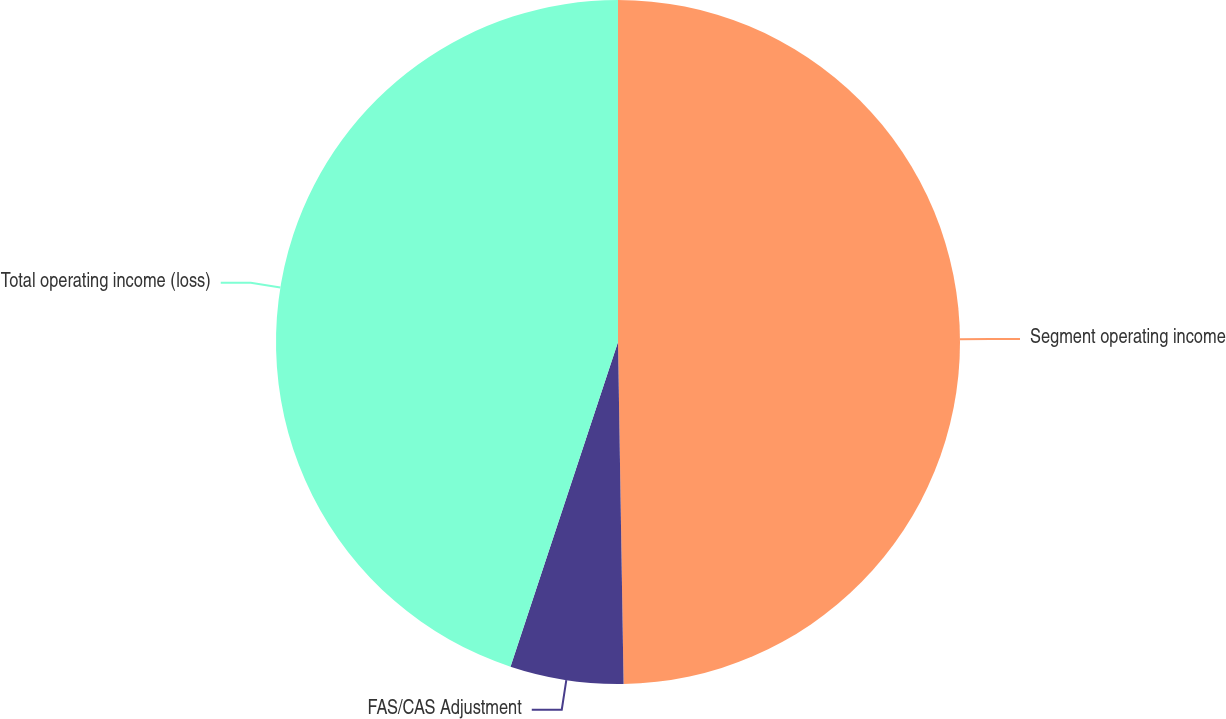Convert chart to OTSL. <chart><loc_0><loc_0><loc_500><loc_500><pie_chart><fcel>Segment operating income<fcel>FAS/CAS Adjustment<fcel>Total operating income (loss)<nl><fcel>49.74%<fcel>5.35%<fcel>44.91%<nl></chart> 